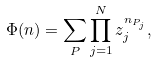<formula> <loc_0><loc_0><loc_500><loc_500>\Phi ( { n } ) = \sum _ { P } \prod _ { j = 1 } ^ { N } z _ { j } ^ { n _ { P _ { j } } } ,</formula> 